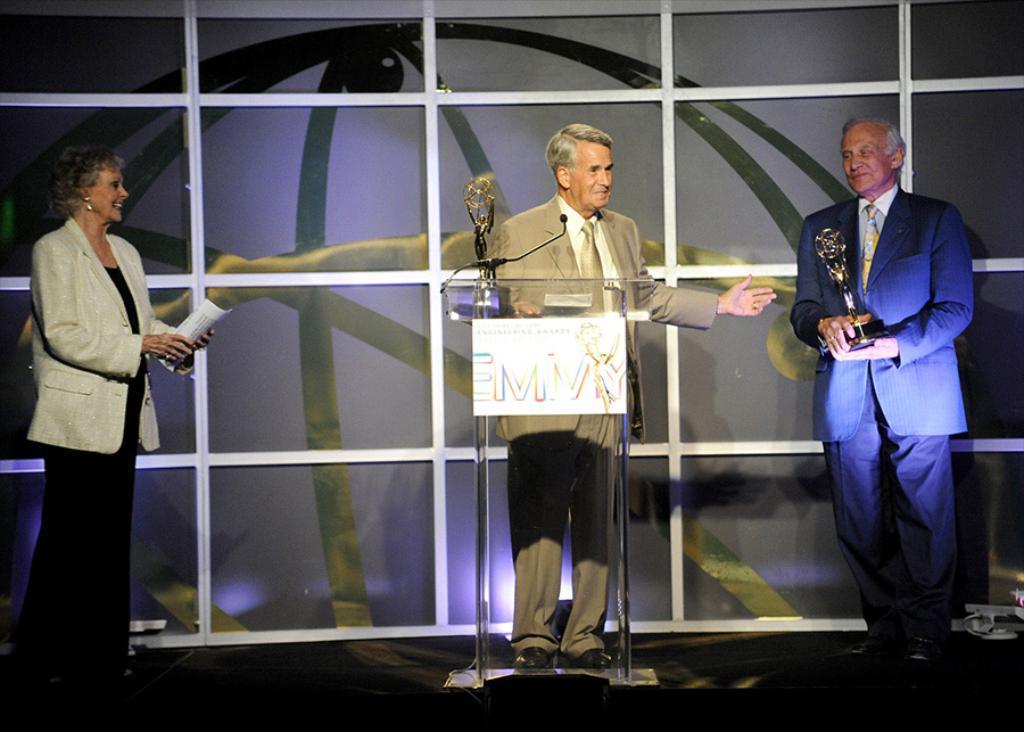Can you describe this image briefly? In this picture we can see three persons are standing, a man on the right side is holding a trophy, there is a podium in the middle, we can see a microphone and another trophy on the podium, there is a board pasted on the podium, a woman on the left side is holding a paper. 